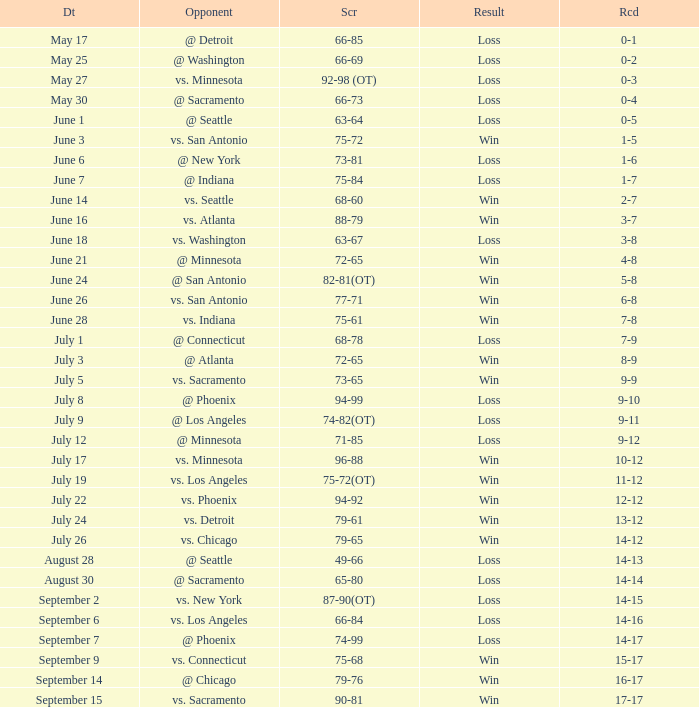What was the Result on July 24? Win. Give me the full table as a dictionary. {'header': ['Dt', 'Opponent', 'Scr', 'Result', 'Rcd'], 'rows': [['May 17', '@ Detroit', '66-85', 'Loss', '0-1'], ['May 25', '@ Washington', '66-69', 'Loss', '0-2'], ['May 27', 'vs. Minnesota', '92-98 (OT)', 'Loss', '0-3'], ['May 30', '@ Sacramento', '66-73', 'Loss', '0-4'], ['June 1', '@ Seattle', '63-64', 'Loss', '0-5'], ['June 3', 'vs. San Antonio', '75-72', 'Win', '1-5'], ['June 6', '@ New York', '73-81', 'Loss', '1-6'], ['June 7', '@ Indiana', '75-84', 'Loss', '1-7'], ['June 14', 'vs. Seattle', '68-60', 'Win', '2-7'], ['June 16', 'vs. Atlanta', '88-79', 'Win', '3-7'], ['June 18', 'vs. Washington', '63-67', 'Loss', '3-8'], ['June 21', '@ Minnesota', '72-65', 'Win', '4-8'], ['June 24', '@ San Antonio', '82-81(OT)', 'Win', '5-8'], ['June 26', 'vs. San Antonio', '77-71', 'Win', '6-8'], ['June 28', 'vs. Indiana', '75-61', 'Win', '7-8'], ['July 1', '@ Connecticut', '68-78', 'Loss', '7-9'], ['July 3', '@ Atlanta', '72-65', 'Win', '8-9'], ['July 5', 'vs. Sacramento', '73-65', 'Win', '9-9'], ['July 8', '@ Phoenix', '94-99', 'Loss', '9-10'], ['July 9', '@ Los Angeles', '74-82(OT)', 'Loss', '9-11'], ['July 12', '@ Minnesota', '71-85', 'Loss', '9-12'], ['July 17', 'vs. Minnesota', '96-88', 'Win', '10-12'], ['July 19', 'vs. Los Angeles', '75-72(OT)', 'Win', '11-12'], ['July 22', 'vs. Phoenix', '94-92', 'Win', '12-12'], ['July 24', 'vs. Detroit', '79-61', 'Win', '13-12'], ['July 26', 'vs. Chicago', '79-65', 'Win', '14-12'], ['August 28', '@ Seattle', '49-66', 'Loss', '14-13'], ['August 30', '@ Sacramento', '65-80', 'Loss', '14-14'], ['September 2', 'vs. New York', '87-90(OT)', 'Loss', '14-15'], ['September 6', 'vs. Los Angeles', '66-84', 'Loss', '14-16'], ['September 7', '@ Phoenix', '74-99', 'Loss', '14-17'], ['September 9', 'vs. Connecticut', '75-68', 'Win', '15-17'], ['September 14', '@ Chicago', '79-76', 'Win', '16-17'], ['September 15', 'vs. Sacramento', '90-81', 'Win', '17-17']]} 